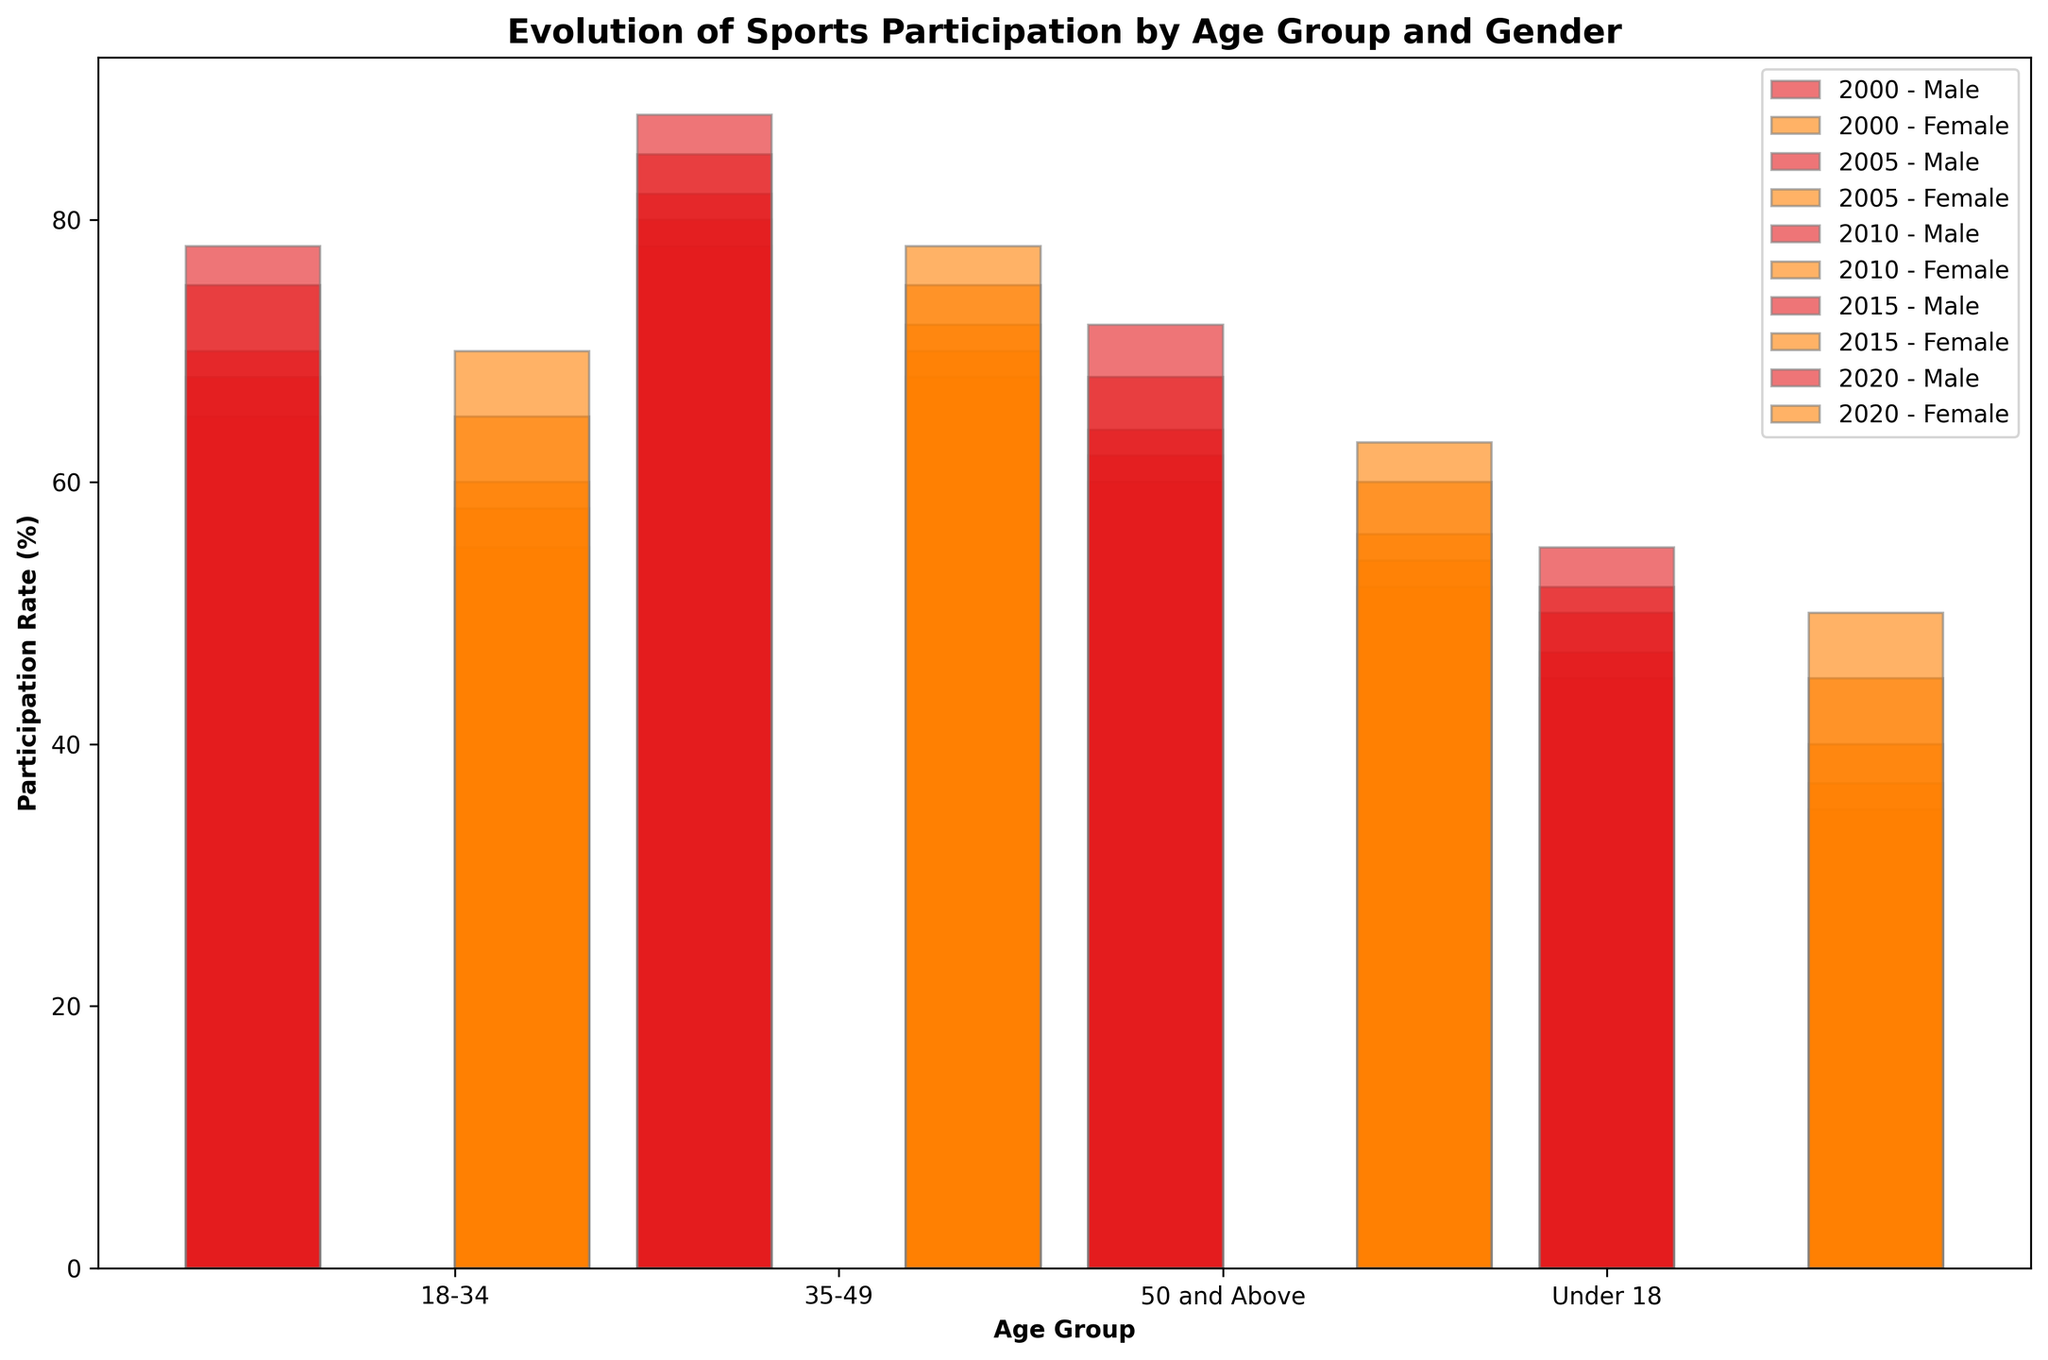Which age group showed the highest increase in participation rate for males from 2000 to 2020? First, check the participation rates for each age group for males in 2000 and 2020. Calculate the difference for each age group: Under 18: 78 - 65 = 13, 18-34: 88 - 78 = 10, 35-49: 72 - 60 = 12, 50 and Above: 55 - 45 = 10. The highest increase is for Under 18 with 13 percentage points.
Answer: Under 18 Between males and females, which gender showed a greater increase in participation rate in the 18-34 age group from 2000 to 2020? Calculate the increase from 2000 to 2020 for the 18-34 age group for both genders. For males: 88 - 78 = 10. For females: 78 - 68 = 10. Both genders showed the same increase in participation.
Answer: Equal What was the average participation rate for females in the 35-49 age group across all years? Add the participation rates for females in the 35-49 age group for all years (2000, 2005, 2010, 2015, 2020) and divide by the number of years: (52 + 54 + 56 + 60 + 63) / 5 = 285 / 5 = 57.
Answer: 57 Which year had the smallest difference in participation rates between males and females in the 50 and Above age group? Calculate the differences for each year: 2000: 45 - 35 = 10, 2005: 47 - 37 = 10, 2010: 50 - 40 = 10, 2015: 52 - 45 = 7, 2020: 55 - 50 = 5. The smallest difference is 5 in 2020.
Answer: 2020 In which age group and year did females see the highest participation rate? Look at all the data points for females across different age groups and years: Under 18 (2020) - 70, 18-34 (2020) - 78, 35-49 (2020) - 63, 50 and Above (2020) - 50. The highest rate is 78 in 18-34 age group in 2020.
Answer: 18-34 in 2020 